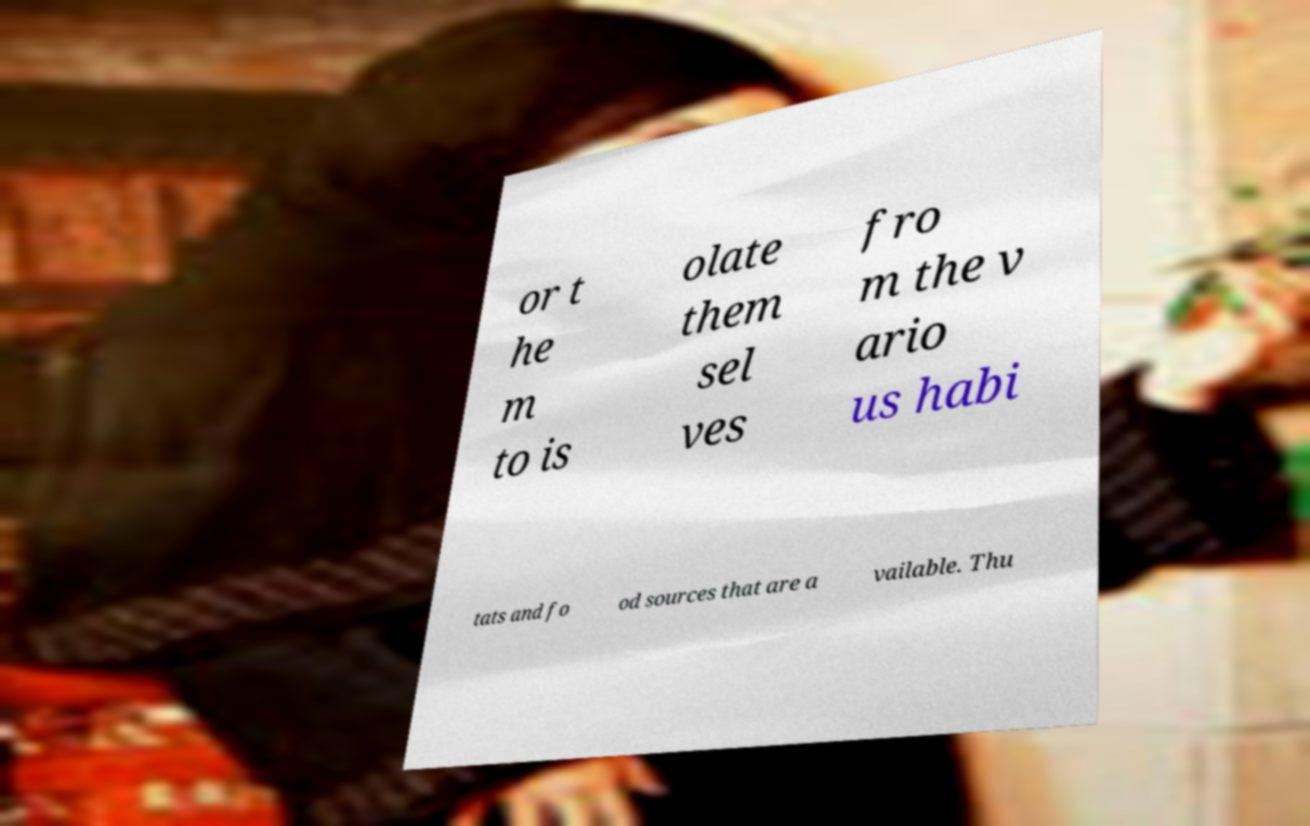Please identify and transcribe the text found in this image. or t he m to is olate them sel ves fro m the v ario us habi tats and fo od sources that are a vailable. Thu 